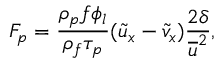<formula> <loc_0><loc_0><loc_500><loc_500>F _ { p } = \frac { \rho _ { p } f \phi _ { l } } { \rho _ { f } \tau _ { p } } ( \widetilde { u } _ { x } - \widetilde { v } _ { x } ) \frac { 2 \delta } { \overline { u } ^ { 2 } } ,</formula> 